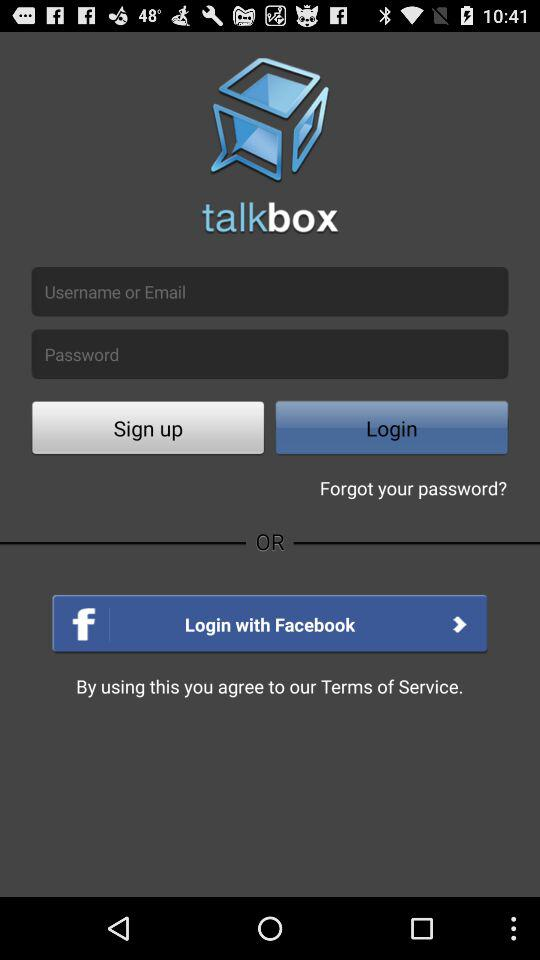How many login options are there?
Answer the question using a single word or phrase. 2 